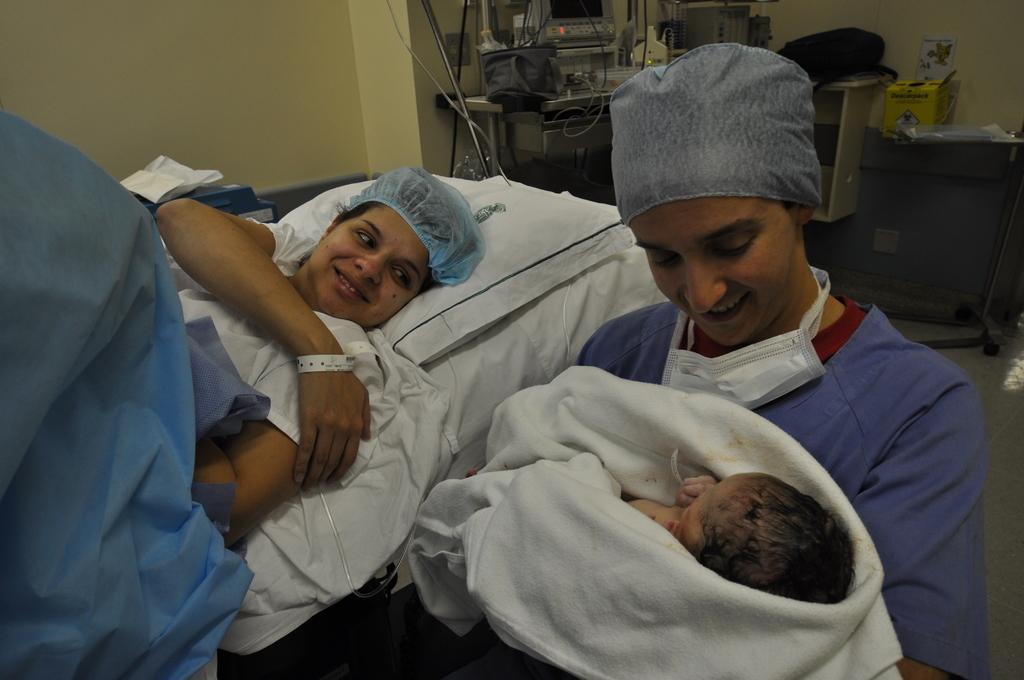Please provide a concise description of this image. In this image I can see a woman laying on bed and she is smiling and I can see a blue color cloth visible on that woman and I can see another woman on the right side ,she holding a baby ,she is smiling ,at the top I can see a machine equipment and wires kept on table and I can see the wall. 